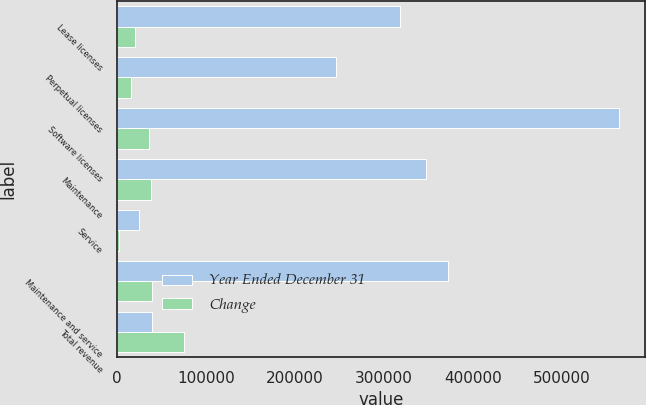Convert chart to OTSL. <chart><loc_0><loc_0><loc_500><loc_500><stacked_bar_chart><ecel><fcel>Lease licenses<fcel>Perpetual licenses<fcel>Software licenses<fcel>Maintenance<fcel>Service<fcel>Maintenance and service<fcel>Total revenue<nl><fcel>Year Ended December 31<fcel>318041<fcel>246461<fcel>564502<fcel>346698<fcel>24821<fcel>371519<fcel>39203<nl><fcel>Change<fcel>20383<fcel>15175<fcel>35558<fcel>37613<fcel>1590<fcel>39203<fcel>74761<nl></chart> 